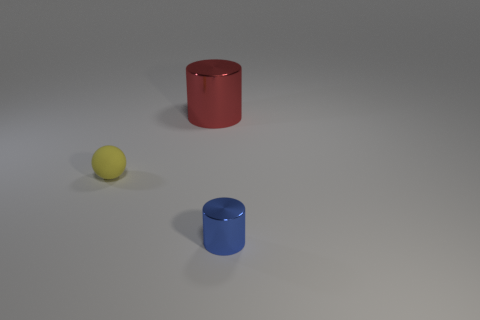What number of other objects are there of the same material as the yellow sphere?
Ensure brevity in your answer.  0. The small blue object that is the same material as the big thing is what shape?
Ensure brevity in your answer.  Cylinder. Is the number of shiny cylinders that are behind the blue metal cylinder greater than the number of cyan matte blocks?
Provide a succinct answer. Yes. Is the shape of the red shiny thing the same as the shiny object that is in front of the red shiny cylinder?
Your answer should be very brief. Yes. What number of shiny objects are the same size as the sphere?
Offer a terse response. 1. How many tiny blue cylinders are right of the cylinder that is left of the cylinder in front of the red metal thing?
Keep it short and to the point. 1. Is the number of red shiny cylinders in front of the red metal cylinder the same as the number of tiny cylinders in front of the tiny yellow object?
Keep it short and to the point. No. How many large red things are the same shape as the tiny yellow rubber thing?
Offer a terse response. 0. Is there a large object made of the same material as the blue cylinder?
Your response must be concise. Yes. What number of tiny blue cylinders are there?
Give a very brief answer. 1. 